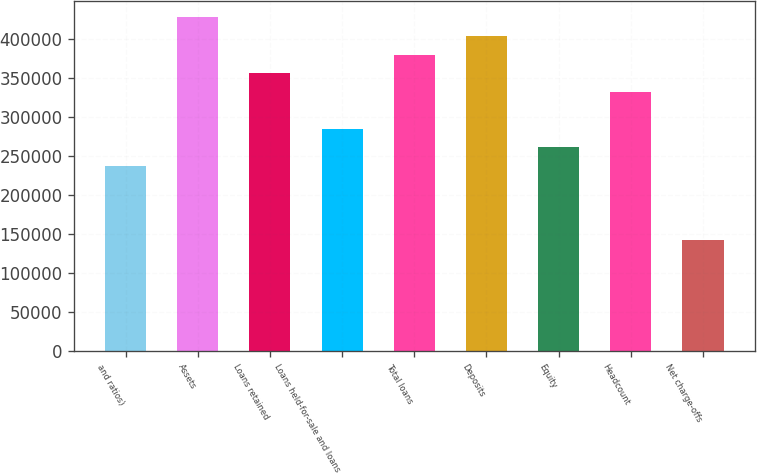<chart> <loc_0><loc_0><loc_500><loc_500><bar_chart><fcel>and ratios)<fcel>Assets<fcel>Loans retained<fcel>Loans held-for-sale and loans<fcel>Total loans<fcel>Deposits<fcel>Equity<fcel>Headcount<fcel>Net charge-offs<nl><fcel>237887<fcel>428196<fcel>356830<fcel>285464<fcel>380619<fcel>404408<fcel>261676<fcel>333042<fcel>142732<nl></chart> 